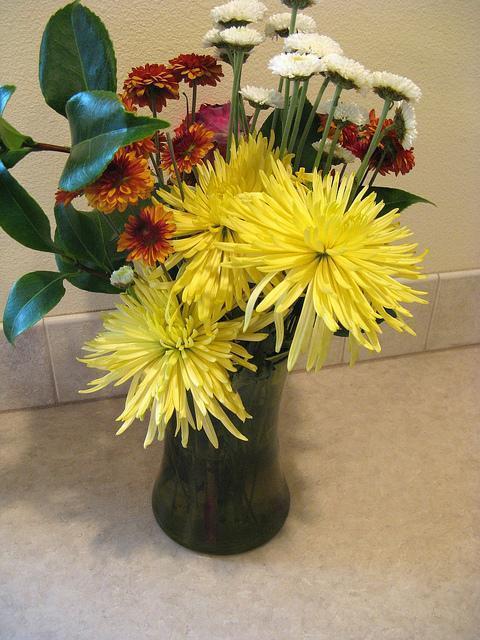How many sheep are there?
Give a very brief answer. 0. 